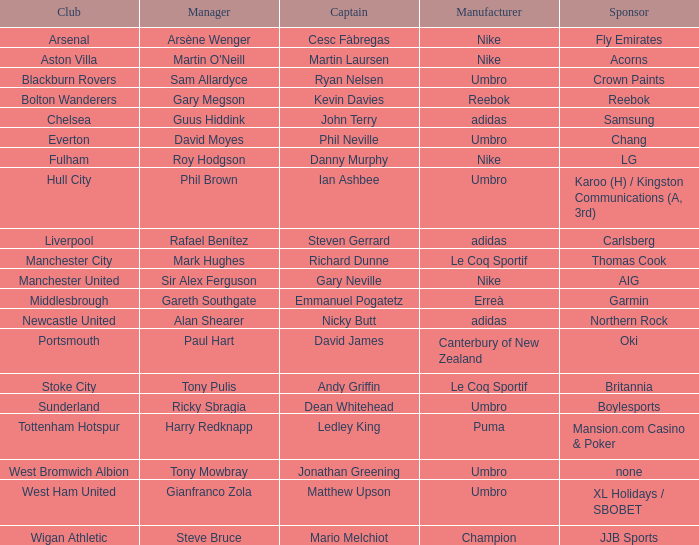Who is Dean Whitehead's manager? Ricky Sbragia. 